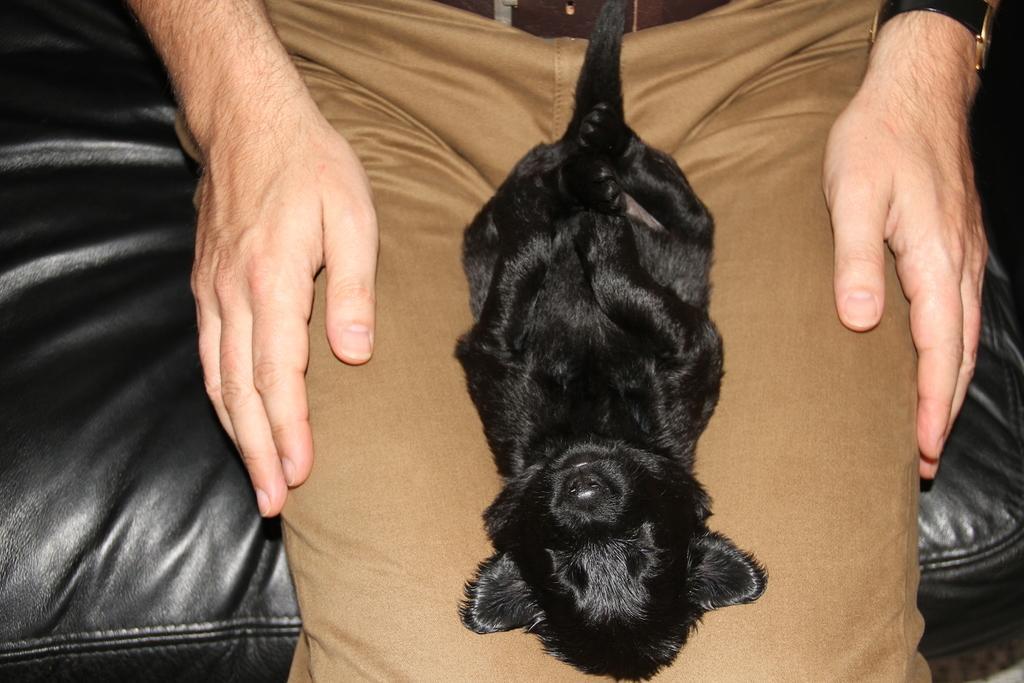Can you describe this image briefly? In this image I can see an animal which is black in color is on the lap of a person who is wearing brown colored pant. I can see the person is sitting on the black colored couch. 